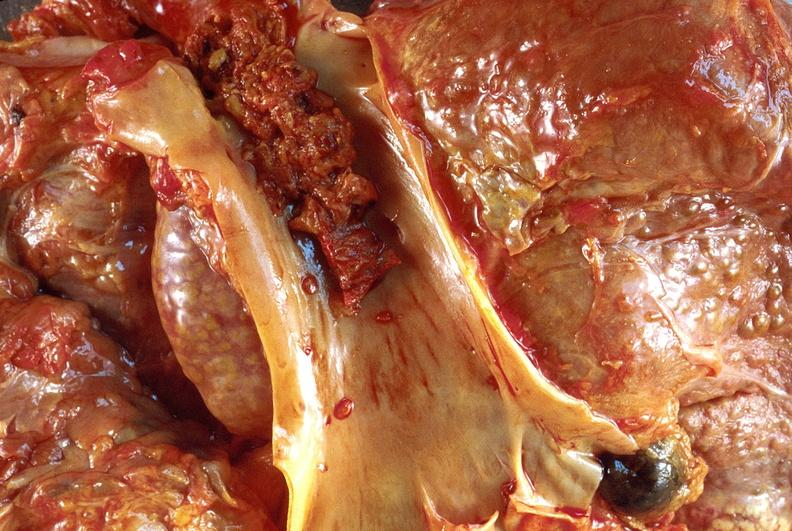s liver present?
Answer the question using a single word or phrase. Yes 